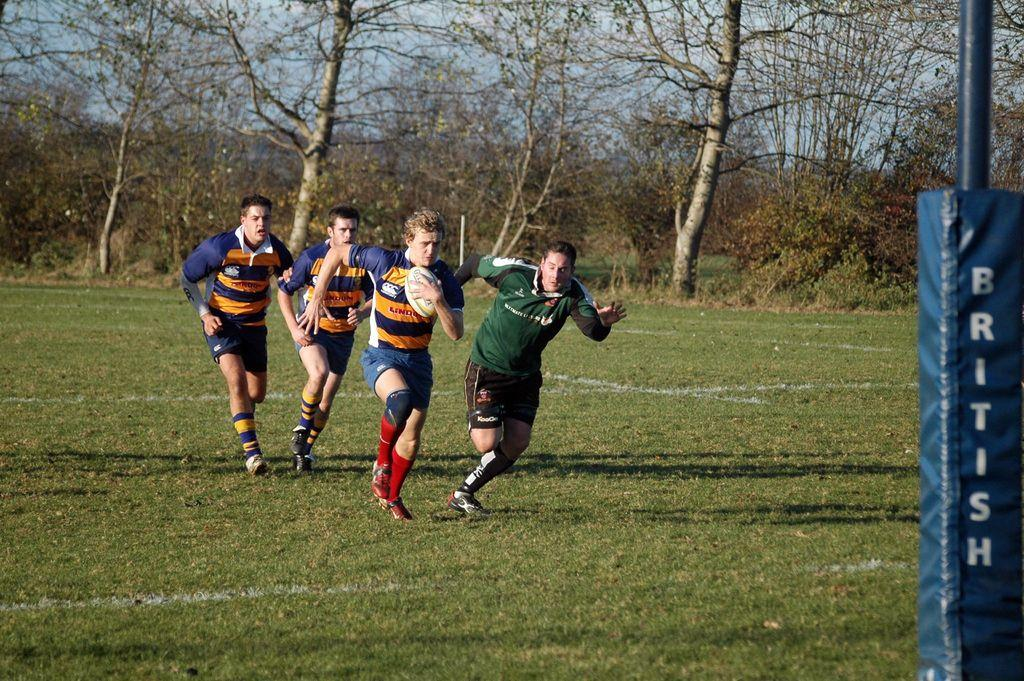How many people are playing rugby in the image? There are four players in the image. What sport are the players engaged in? The players are playing rugby. Where is the game taking place? The game is taking place on the ground. What can be seen in the background of the image? There are dry trees in the background of the image. What type of voice can be heard coming from the trees in the image? There is no voice coming from the trees in the image, as trees do not have the ability to produce sound. 